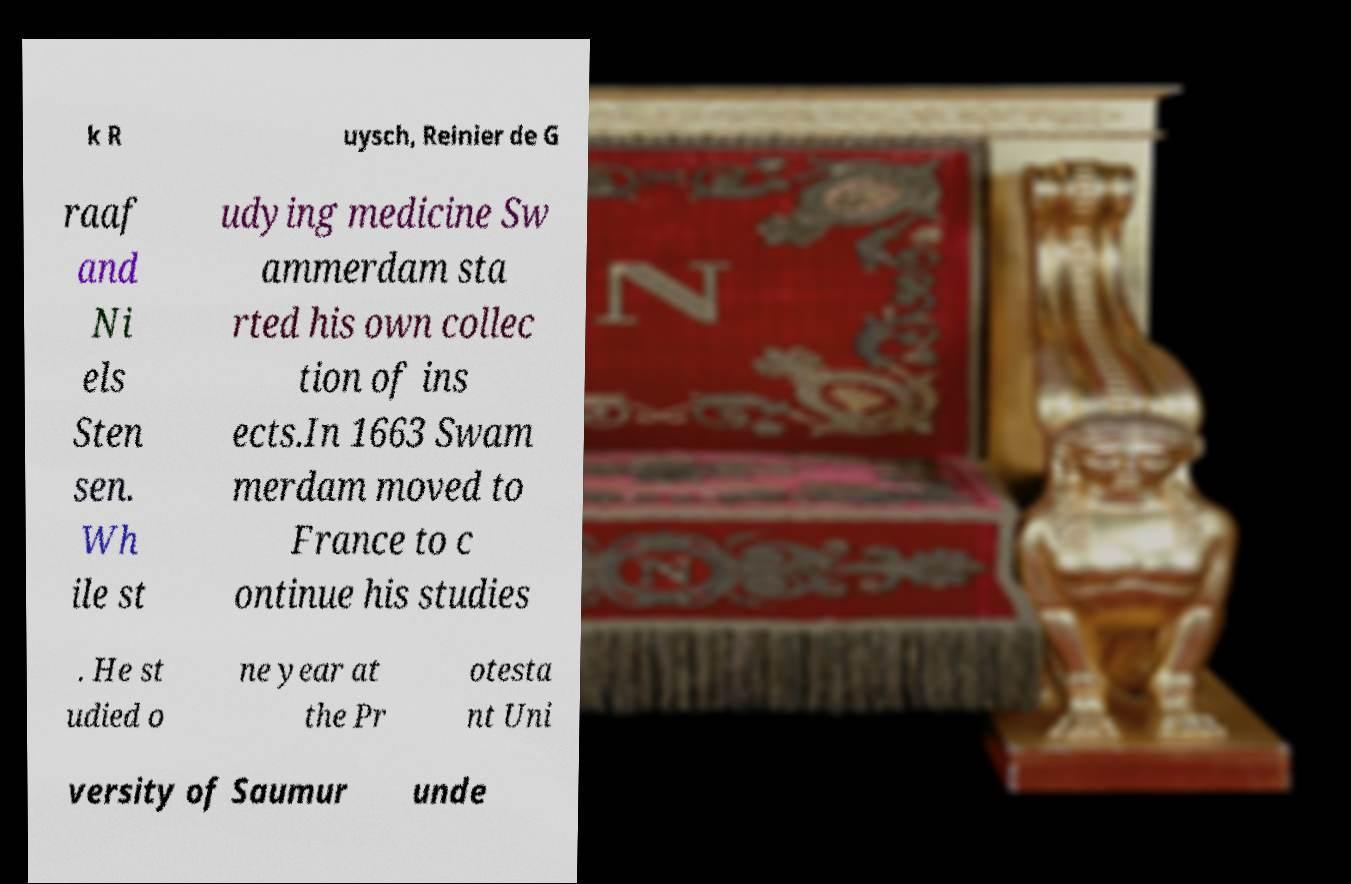For documentation purposes, I need the text within this image transcribed. Could you provide that? k R uysch, Reinier de G raaf and Ni els Sten sen. Wh ile st udying medicine Sw ammerdam sta rted his own collec tion of ins ects.In 1663 Swam merdam moved to France to c ontinue his studies . He st udied o ne year at the Pr otesta nt Uni versity of Saumur unde 